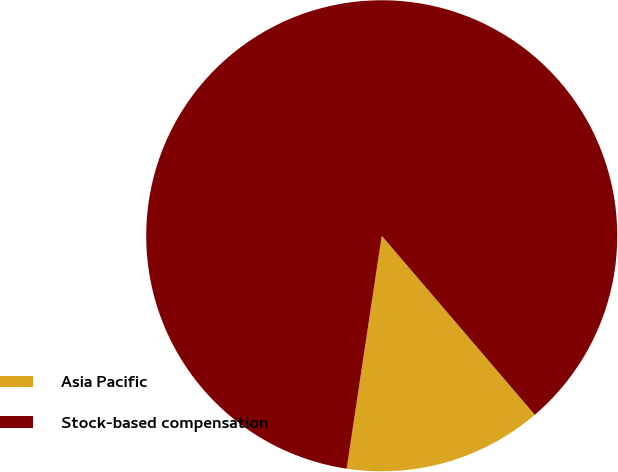Convert chart. <chart><loc_0><loc_0><loc_500><loc_500><pie_chart><fcel>Asia Pacific<fcel>Stock-based compensation<nl><fcel>13.64%<fcel>86.36%<nl></chart> 